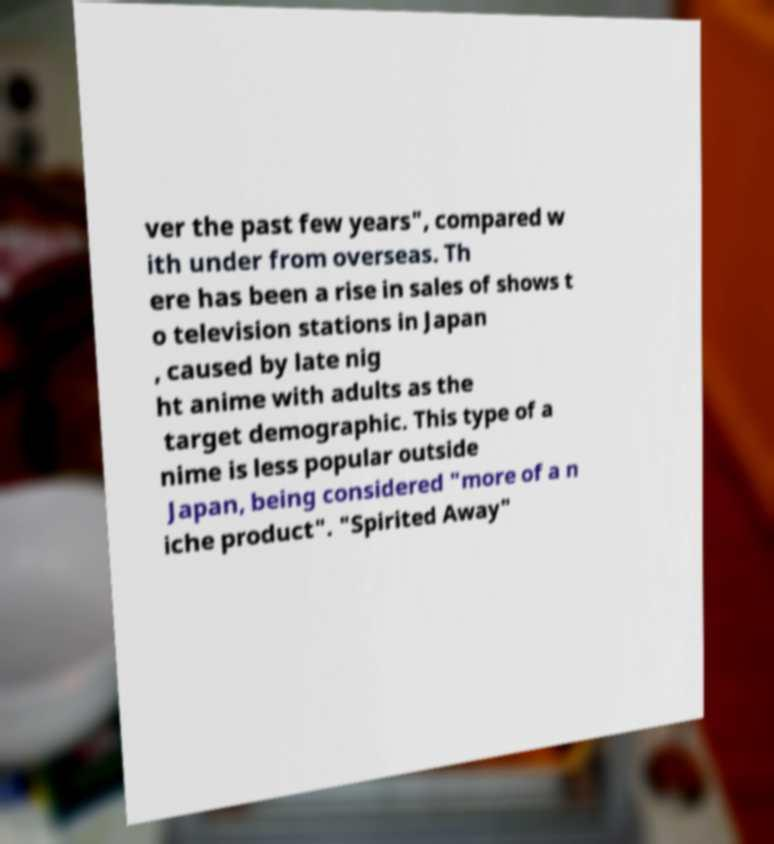What messages or text are displayed in this image? I need them in a readable, typed format. ver the past few years", compared w ith under from overseas. Th ere has been a rise in sales of shows t o television stations in Japan , caused by late nig ht anime with adults as the target demographic. This type of a nime is less popular outside Japan, being considered "more of a n iche product". "Spirited Away" 